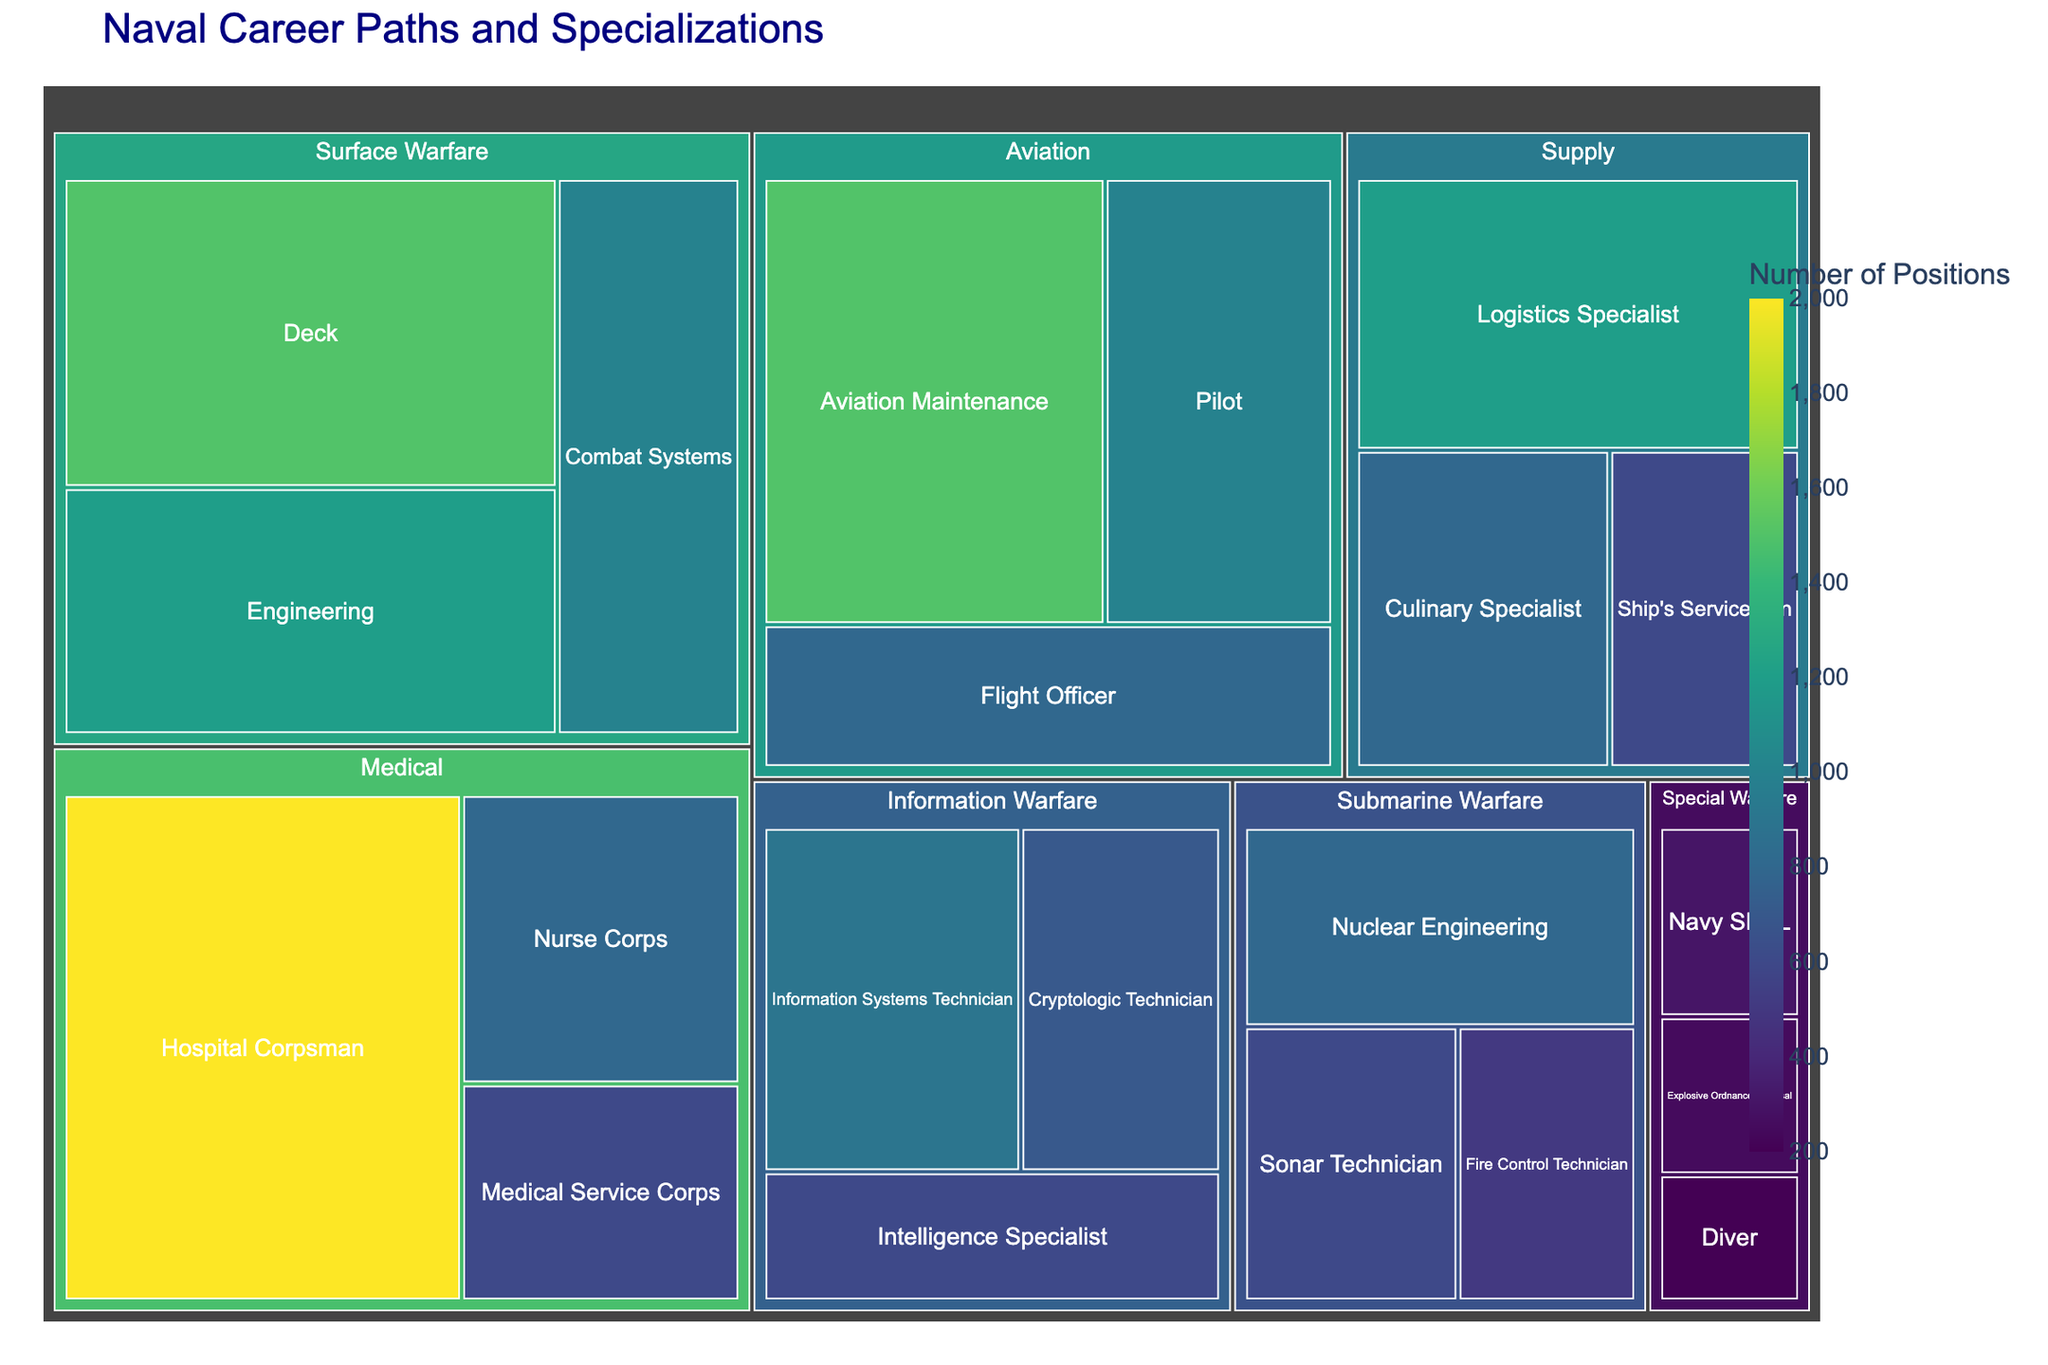what is the title of the figure? The title of a figure is usually displayed at the top and serves as a brief description of what the figure represents. In this treemap, you can see the title at the top center of the plot.
Answer: Naval Career Paths and Specializations How many total positions are in the "Medical" career path? To determine the total number of positions in the "Medical" career path, sum the positions of the three specializations under "Medical": Hospital Corpsman (2000), Nurse Corps (800), and Medical Service Corps (600).
Answer: 3400 Which specialization within "Aviation" has the fewest positions available? Look at the three specializations under "Aviation": Pilot (1000), Flight Officer (800), and Aviation Maintenance (1500). The one with the smallest value is the Flight Officer.
Answer: Flight Officer How does the number of positions for "Information Systems Technician" compare to "Cryptologic Technician"? Look at the two specializations under "Information Warfare". "Information Systems Technician" has 900 positions while "Cryptologic Technician" has 700 positions.
Answer: Information Systems Technician has 200 more positions than Cryptologic Technician Which career path has the smallest specialization in terms of positions available? Examine the smallest values for each career path. The smallest specialization is Diver under "Special Warfare" with 200 positions.
Answer: Special Warfare (Diver) What is the total number of positions available in the "Surface Warfare" career path? Add up the positions for the specializations under "Surface Warfare": Deck (1500), Engineering (1200), and Combat Systems (1000).
Answer: 3700 Which career path has the highest total number of positions? Sum the positions within each career path and identify the one with the largest total. Medical has the highest total with 3400 positions.
Answer: Medical Compare the total number of positions in "Submarine Warfare" to "Special Warfare". Which has more? Add the positions under "Submarine Warfare": Nuclear Engineering (800), Sonar Technician (600), Fire Control Technician (500). Then add positions under "Special Warfare": Navy SEAL (300), Explosive Ordnance Disposal (250), Diver (200). Submarine Warfare has 1900 and Special Warfare has 750.
Answer: Submarine Warfare has more positions What is the difference between the total number of positions in "Supply" and "Aviation"? Sum the positions for Supply: Logistics Specialist (1200), Culinary Specialist (800), Ship's Serviceman (600), which totals 2600. Sum the positions for Aviation: Pilot (1000), Flight Officer (800), Aviation Maintenance (1500), which totals 3300. The difference is 3300 - 2600 = 700.
Answer: 700 Which specialization under "Information Warfare" has the largest number of positions? Look at the three specializations under "Information Warfare": Cryptologic Technician (700), Intelligence Specialist (600), and Information Systems Technician (900). The largest value is for Information Systems Technician.
Answer: Information Systems Technician 